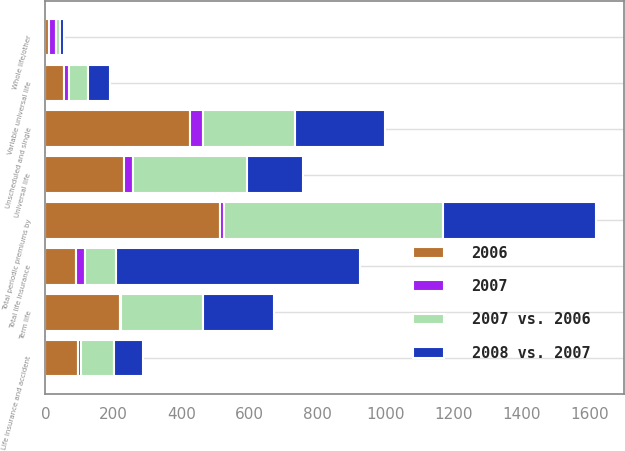Convert chart to OTSL. <chart><loc_0><loc_0><loc_500><loc_500><stacked_bar_chart><ecel><fcel>Universal life<fcel>Variable universal life<fcel>Term life<fcel>Whole life/other<fcel>Total periodic premiums by<fcel>Unscheduled and single<fcel>Total life insurance<fcel>Life insurance and accident<nl><fcel>2008 vs. 2007<fcel>167<fcel>63<fcel>210<fcel>11<fcel>451<fcel>267<fcel>718<fcel>87<nl><fcel>2006<fcel>230<fcel>55<fcel>219<fcel>9<fcel>513<fcel>426<fcel>91<fcel>96<nl><fcel>2007 vs. 2006<fcel>334<fcel>56<fcel>240<fcel>13<fcel>643<fcel>269<fcel>91<fcel>95<nl><fcel>2007<fcel>27<fcel>15<fcel>4<fcel>22<fcel>12<fcel>37<fcel>24<fcel>9<nl></chart> 